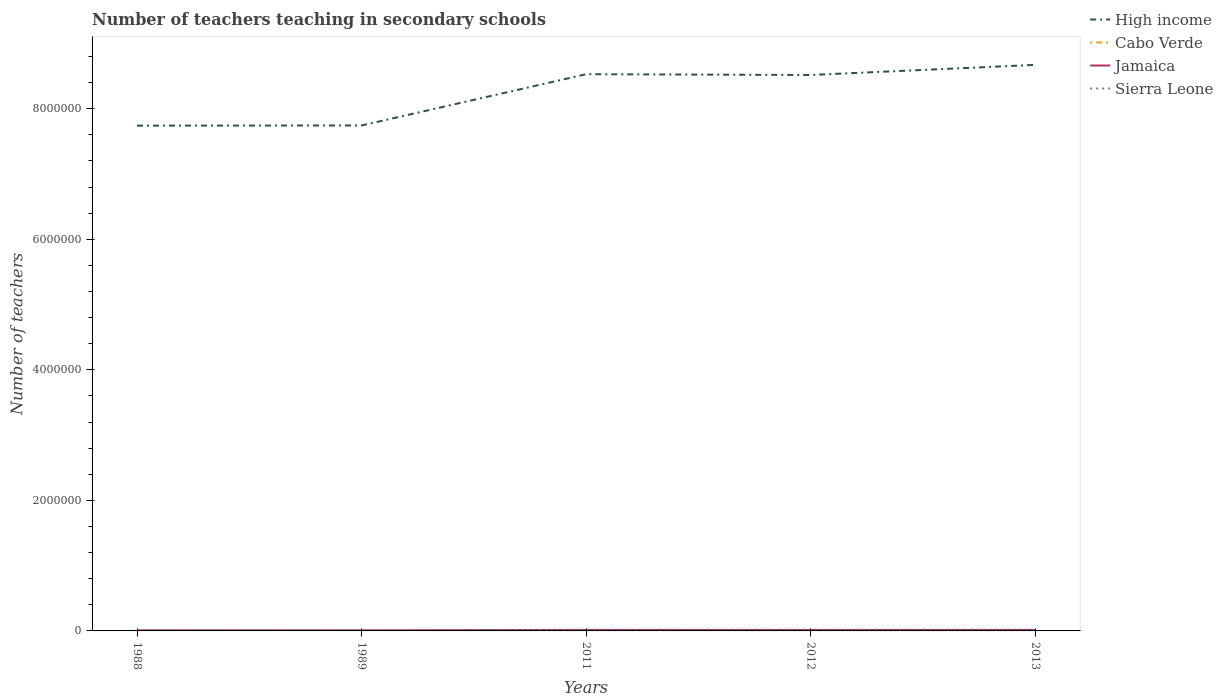How many different coloured lines are there?
Your response must be concise. 4. Does the line corresponding to High income intersect with the line corresponding to Jamaica?
Your answer should be very brief. No. Across all years, what is the maximum number of teachers teaching in secondary schools in Sierra Leone?
Provide a short and direct response. 5130. What is the total number of teachers teaching in secondary schools in High income in the graph?
Ensure brevity in your answer.  -9.28e+05. What is the difference between the highest and the second highest number of teachers teaching in secondary schools in Jamaica?
Provide a succinct answer. 6449. What is the difference between the highest and the lowest number of teachers teaching in secondary schools in Cabo Verde?
Offer a very short reply. 3. Does the graph contain any zero values?
Ensure brevity in your answer.  No. Does the graph contain grids?
Offer a very short reply. No. How many legend labels are there?
Offer a very short reply. 4. What is the title of the graph?
Your response must be concise. Number of teachers teaching in secondary schools. Does "Hungary" appear as one of the legend labels in the graph?
Make the answer very short. No. What is the label or title of the X-axis?
Your response must be concise. Years. What is the label or title of the Y-axis?
Offer a terse response. Number of teachers. What is the Number of teachers of High income in 1988?
Provide a succinct answer. 7.74e+06. What is the Number of teachers of Cabo Verde in 1988?
Keep it short and to the point. 268. What is the Number of teachers in Jamaica in 1988?
Your response must be concise. 9037. What is the Number of teachers of Sierra Leone in 1988?
Your response must be concise. 5820. What is the Number of teachers of High income in 1989?
Your answer should be compact. 7.74e+06. What is the Number of teachers of Cabo Verde in 1989?
Your answer should be very brief. 291. What is the Number of teachers of Jamaica in 1989?
Offer a terse response. 9061. What is the Number of teachers of Sierra Leone in 1989?
Keep it short and to the point. 5130. What is the Number of teachers of High income in 2011?
Make the answer very short. 8.53e+06. What is the Number of teachers in Cabo Verde in 2011?
Provide a short and direct response. 3614. What is the Number of teachers in Jamaica in 2011?
Offer a very short reply. 1.55e+04. What is the Number of teachers of Sierra Leone in 2011?
Keep it short and to the point. 1.72e+04. What is the Number of teachers of High income in 2012?
Your response must be concise. 8.52e+06. What is the Number of teachers of Cabo Verde in 2012?
Provide a succinct answer. 3689. What is the Number of teachers in Jamaica in 2012?
Your response must be concise. 1.43e+04. What is the Number of teachers in Sierra Leone in 2012?
Keep it short and to the point. 1.85e+04. What is the Number of teachers in High income in 2013?
Keep it short and to the point. 8.67e+06. What is the Number of teachers of Cabo Verde in 2013?
Keep it short and to the point. 3624. What is the Number of teachers of Jamaica in 2013?
Give a very brief answer. 1.42e+04. What is the Number of teachers in Sierra Leone in 2013?
Offer a terse response. 2.02e+04. Across all years, what is the maximum Number of teachers of High income?
Ensure brevity in your answer.  8.67e+06. Across all years, what is the maximum Number of teachers of Cabo Verde?
Provide a short and direct response. 3689. Across all years, what is the maximum Number of teachers of Jamaica?
Your response must be concise. 1.55e+04. Across all years, what is the maximum Number of teachers of Sierra Leone?
Keep it short and to the point. 2.02e+04. Across all years, what is the minimum Number of teachers of High income?
Offer a very short reply. 7.74e+06. Across all years, what is the minimum Number of teachers of Cabo Verde?
Your answer should be compact. 268. Across all years, what is the minimum Number of teachers in Jamaica?
Provide a succinct answer. 9037. Across all years, what is the minimum Number of teachers of Sierra Leone?
Your response must be concise. 5130. What is the total Number of teachers of High income in the graph?
Ensure brevity in your answer.  4.12e+07. What is the total Number of teachers of Cabo Verde in the graph?
Offer a terse response. 1.15e+04. What is the total Number of teachers in Jamaica in the graph?
Provide a succinct answer. 6.20e+04. What is the total Number of teachers of Sierra Leone in the graph?
Ensure brevity in your answer.  6.68e+04. What is the difference between the Number of teachers of High income in 1988 and that in 1989?
Your answer should be compact. -2848. What is the difference between the Number of teachers in Jamaica in 1988 and that in 1989?
Your response must be concise. -24. What is the difference between the Number of teachers in Sierra Leone in 1988 and that in 1989?
Make the answer very short. 690. What is the difference between the Number of teachers of High income in 1988 and that in 2011?
Keep it short and to the point. -7.88e+05. What is the difference between the Number of teachers of Cabo Verde in 1988 and that in 2011?
Your response must be concise. -3346. What is the difference between the Number of teachers in Jamaica in 1988 and that in 2011?
Ensure brevity in your answer.  -6449. What is the difference between the Number of teachers in Sierra Leone in 1988 and that in 2011?
Offer a very short reply. -1.14e+04. What is the difference between the Number of teachers of High income in 1988 and that in 2012?
Your answer should be compact. -7.76e+05. What is the difference between the Number of teachers of Cabo Verde in 1988 and that in 2012?
Provide a succinct answer. -3421. What is the difference between the Number of teachers of Jamaica in 1988 and that in 2012?
Provide a short and direct response. -5219. What is the difference between the Number of teachers in Sierra Leone in 1988 and that in 2012?
Ensure brevity in your answer.  -1.27e+04. What is the difference between the Number of teachers in High income in 1988 and that in 2013?
Offer a terse response. -9.31e+05. What is the difference between the Number of teachers in Cabo Verde in 1988 and that in 2013?
Provide a succinct answer. -3356. What is the difference between the Number of teachers in Jamaica in 1988 and that in 2013?
Provide a short and direct response. -5113. What is the difference between the Number of teachers of Sierra Leone in 1988 and that in 2013?
Give a very brief answer. -1.44e+04. What is the difference between the Number of teachers in High income in 1989 and that in 2011?
Your answer should be very brief. -7.85e+05. What is the difference between the Number of teachers of Cabo Verde in 1989 and that in 2011?
Your answer should be compact. -3323. What is the difference between the Number of teachers in Jamaica in 1989 and that in 2011?
Provide a short and direct response. -6425. What is the difference between the Number of teachers in Sierra Leone in 1989 and that in 2011?
Provide a short and direct response. -1.21e+04. What is the difference between the Number of teachers of High income in 1989 and that in 2012?
Make the answer very short. -7.73e+05. What is the difference between the Number of teachers in Cabo Verde in 1989 and that in 2012?
Give a very brief answer. -3398. What is the difference between the Number of teachers in Jamaica in 1989 and that in 2012?
Keep it short and to the point. -5195. What is the difference between the Number of teachers in Sierra Leone in 1989 and that in 2012?
Offer a terse response. -1.34e+04. What is the difference between the Number of teachers in High income in 1989 and that in 2013?
Provide a succinct answer. -9.28e+05. What is the difference between the Number of teachers in Cabo Verde in 1989 and that in 2013?
Your answer should be very brief. -3333. What is the difference between the Number of teachers in Jamaica in 1989 and that in 2013?
Ensure brevity in your answer.  -5089. What is the difference between the Number of teachers of Sierra Leone in 1989 and that in 2013?
Ensure brevity in your answer.  -1.51e+04. What is the difference between the Number of teachers in High income in 2011 and that in 2012?
Your response must be concise. 1.19e+04. What is the difference between the Number of teachers of Cabo Verde in 2011 and that in 2012?
Offer a very short reply. -75. What is the difference between the Number of teachers in Jamaica in 2011 and that in 2012?
Offer a terse response. 1230. What is the difference between the Number of teachers of Sierra Leone in 2011 and that in 2012?
Offer a very short reply. -1288. What is the difference between the Number of teachers in High income in 2011 and that in 2013?
Offer a terse response. -1.43e+05. What is the difference between the Number of teachers of Cabo Verde in 2011 and that in 2013?
Your response must be concise. -10. What is the difference between the Number of teachers of Jamaica in 2011 and that in 2013?
Your answer should be very brief. 1336. What is the difference between the Number of teachers of Sierra Leone in 2011 and that in 2013?
Your answer should be compact. -3002. What is the difference between the Number of teachers in High income in 2012 and that in 2013?
Provide a short and direct response. -1.55e+05. What is the difference between the Number of teachers of Jamaica in 2012 and that in 2013?
Offer a terse response. 106. What is the difference between the Number of teachers in Sierra Leone in 2012 and that in 2013?
Your answer should be very brief. -1714. What is the difference between the Number of teachers in High income in 1988 and the Number of teachers in Cabo Verde in 1989?
Your response must be concise. 7.74e+06. What is the difference between the Number of teachers in High income in 1988 and the Number of teachers in Jamaica in 1989?
Provide a succinct answer. 7.73e+06. What is the difference between the Number of teachers of High income in 1988 and the Number of teachers of Sierra Leone in 1989?
Keep it short and to the point. 7.74e+06. What is the difference between the Number of teachers of Cabo Verde in 1988 and the Number of teachers of Jamaica in 1989?
Your answer should be compact. -8793. What is the difference between the Number of teachers of Cabo Verde in 1988 and the Number of teachers of Sierra Leone in 1989?
Your answer should be compact. -4862. What is the difference between the Number of teachers in Jamaica in 1988 and the Number of teachers in Sierra Leone in 1989?
Offer a very short reply. 3907. What is the difference between the Number of teachers of High income in 1988 and the Number of teachers of Cabo Verde in 2011?
Give a very brief answer. 7.74e+06. What is the difference between the Number of teachers in High income in 1988 and the Number of teachers in Jamaica in 2011?
Keep it short and to the point. 7.72e+06. What is the difference between the Number of teachers in High income in 1988 and the Number of teachers in Sierra Leone in 2011?
Offer a terse response. 7.72e+06. What is the difference between the Number of teachers of Cabo Verde in 1988 and the Number of teachers of Jamaica in 2011?
Make the answer very short. -1.52e+04. What is the difference between the Number of teachers of Cabo Verde in 1988 and the Number of teachers of Sierra Leone in 2011?
Offer a terse response. -1.69e+04. What is the difference between the Number of teachers in Jamaica in 1988 and the Number of teachers in Sierra Leone in 2011?
Your answer should be very brief. -8157. What is the difference between the Number of teachers in High income in 1988 and the Number of teachers in Cabo Verde in 2012?
Keep it short and to the point. 7.74e+06. What is the difference between the Number of teachers of High income in 1988 and the Number of teachers of Jamaica in 2012?
Provide a succinct answer. 7.73e+06. What is the difference between the Number of teachers in High income in 1988 and the Number of teachers in Sierra Leone in 2012?
Give a very brief answer. 7.72e+06. What is the difference between the Number of teachers in Cabo Verde in 1988 and the Number of teachers in Jamaica in 2012?
Offer a terse response. -1.40e+04. What is the difference between the Number of teachers in Cabo Verde in 1988 and the Number of teachers in Sierra Leone in 2012?
Offer a very short reply. -1.82e+04. What is the difference between the Number of teachers of Jamaica in 1988 and the Number of teachers of Sierra Leone in 2012?
Offer a very short reply. -9445. What is the difference between the Number of teachers in High income in 1988 and the Number of teachers in Cabo Verde in 2013?
Offer a very short reply. 7.74e+06. What is the difference between the Number of teachers of High income in 1988 and the Number of teachers of Jamaica in 2013?
Provide a succinct answer. 7.73e+06. What is the difference between the Number of teachers of High income in 1988 and the Number of teachers of Sierra Leone in 2013?
Offer a terse response. 7.72e+06. What is the difference between the Number of teachers in Cabo Verde in 1988 and the Number of teachers in Jamaica in 2013?
Provide a short and direct response. -1.39e+04. What is the difference between the Number of teachers in Cabo Verde in 1988 and the Number of teachers in Sierra Leone in 2013?
Keep it short and to the point. -1.99e+04. What is the difference between the Number of teachers in Jamaica in 1988 and the Number of teachers in Sierra Leone in 2013?
Provide a short and direct response. -1.12e+04. What is the difference between the Number of teachers of High income in 1989 and the Number of teachers of Cabo Verde in 2011?
Provide a succinct answer. 7.74e+06. What is the difference between the Number of teachers of High income in 1989 and the Number of teachers of Jamaica in 2011?
Your answer should be very brief. 7.73e+06. What is the difference between the Number of teachers in High income in 1989 and the Number of teachers in Sierra Leone in 2011?
Offer a very short reply. 7.73e+06. What is the difference between the Number of teachers of Cabo Verde in 1989 and the Number of teachers of Jamaica in 2011?
Make the answer very short. -1.52e+04. What is the difference between the Number of teachers of Cabo Verde in 1989 and the Number of teachers of Sierra Leone in 2011?
Your answer should be compact. -1.69e+04. What is the difference between the Number of teachers in Jamaica in 1989 and the Number of teachers in Sierra Leone in 2011?
Provide a succinct answer. -8133. What is the difference between the Number of teachers in High income in 1989 and the Number of teachers in Cabo Verde in 2012?
Ensure brevity in your answer.  7.74e+06. What is the difference between the Number of teachers in High income in 1989 and the Number of teachers in Jamaica in 2012?
Offer a terse response. 7.73e+06. What is the difference between the Number of teachers in High income in 1989 and the Number of teachers in Sierra Leone in 2012?
Ensure brevity in your answer.  7.72e+06. What is the difference between the Number of teachers in Cabo Verde in 1989 and the Number of teachers in Jamaica in 2012?
Provide a succinct answer. -1.40e+04. What is the difference between the Number of teachers of Cabo Verde in 1989 and the Number of teachers of Sierra Leone in 2012?
Give a very brief answer. -1.82e+04. What is the difference between the Number of teachers of Jamaica in 1989 and the Number of teachers of Sierra Leone in 2012?
Your answer should be compact. -9421. What is the difference between the Number of teachers of High income in 1989 and the Number of teachers of Cabo Verde in 2013?
Your answer should be compact. 7.74e+06. What is the difference between the Number of teachers of High income in 1989 and the Number of teachers of Jamaica in 2013?
Ensure brevity in your answer.  7.73e+06. What is the difference between the Number of teachers of High income in 1989 and the Number of teachers of Sierra Leone in 2013?
Offer a very short reply. 7.72e+06. What is the difference between the Number of teachers of Cabo Verde in 1989 and the Number of teachers of Jamaica in 2013?
Provide a succinct answer. -1.39e+04. What is the difference between the Number of teachers of Cabo Verde in 1989 and the Number of teachers of Sierra Leone in 2013?
Provide a succinct answer. -1.99e+04. What is the difference between the Number of teachers of Jamaica in 1989 and the Number of teachers of Sierra Leone in 2013?
Ensure brevity in your answer.  -1.11e+04. What is the difference between the Number of teachers in High income in 2011 and the Number of teachers in Cabo Verde in 2012?
Your answer should be very brief. 8.52e+06. What is the difference between the Number of teachers of High income in 2011 and the Number of teachers of Jamaica in 2012?
Your answer should be very brief. 8.51e+06. What is the difference between the Number of teachers in High income in 2011 and the Number of teachers in Sierra Leone in 2012?
Make the answer very short. 8.51e+06. What is the difference between the Number of teachers of Cabo Verde in 2011 and the Number of teachers of Jamaica in 2012?
Offer a very short reply. -1.06e+04. What is the difference between the Number of teachers in Cabo Verde in 2011 and the Number of teachers in Sierra Leone in 2012?
Your response must be concise. -1.49e+04. What is the difference between the Number of teachers in Jamaica in 2011 and the Number of teachers in Sierra Leone in 2012?
Give a very brief answer. -2996. What is the difference between the Number of teachers of High income in 2011 and the Number of teachers of Cabo Verde in 2013?
Your answer should be compact. 8.52e+06. What is the difference between the Number of teachers of High income in 2011 and the Number of teachers of Jamaica in 2013?
Provide a short and direct response. 8.51e+06. What is the difference between the Number of teachers in High income in 2011 and the Number of teachers in Sierra Leone in 2013?
Offer a very short reply. 8.51e+06. What is the difference between the Number of teachers of Cabo Verde in 2011 and the Number of teachers of Jamaica in 2013?
Provide a succinct answer. -1.05e+04. What is the difference between the Number of teachers of Cabo Verde in 2011 and the Number of teachers of Sierra Leone in 2013?
Ensure brevity in your answer.  -1.66e+04. What is the difference between the Number of teachers in Jamaica in 2011 and the Number of teachers in Sierra Leone in 2013?
Your answer should be compact. -4710. What is the difference between the Number of teachers of High income in 2012 and the Number of teachers of Cabo Verde in 2013?
Your answer should be compact. 8.51e+06. What is the difference between the Number of teachers of High income in 2012 and the Number of teachers of Jamaica in 2013?
Your answer should be compact. 8.50e+06. What is the difference between the Number of teachers in High income in 2012 and the Number of teachers in Sierra Leone in 2013?
Give a very brief answer. 8.50e+06. What is the difference between the Number of teachers of Cabo Verde in 2012 and the Number of teachers of Jamaica in 2013?
Your answer should be very brief. -1.05e+04. What is the difference between the Number of teachers in Cabo Verde in 2012 and the Number of teachers in Sierra Leone in 2013?
Offer a terse response. -1.65e+04. What is the difference between the Number of teachers of Jamaica in 2012 and the Number of teachers of Sierra Leone in 2013?
Provide a succinct answer. -5940. What is the average Number of teachers of High income per year?
Give a very brief answer. 8.24e+06. What is the average Number of teachers of Cabo Verde per year?
Keep it short and to the point. 2297.2. What is the average Number of teachers of Jamaica per year?
Your answer should be very brief. 1.24e+04. What is the average Number of teachers in Sierra Leone per year?
Your answer should be very brief. 1.34e+04. In the year 1988, what is the difference between the Number of teachers in High income and Number of teachers in Cabo Verde?
Your answer should be very brief. 7.74e+06. In the year 1988, what is the difference between the Number of teachers in High income and Number of teachers in Jamaica?
Give a very brief answer. 7.73e+06. In the year 1988, what is the difference between the Number of teachers of High income and Number of teachers of Sierra Leone?
Offer a terse response. 7.73e+06. In the year 1988, what is the difference between the Number of teachers of Cabo Verde and Number of teachers of Jamaica?
Provide a succinct answer. -8769. In the year 1988, what is the difference between the Number of teachers of Cabo Verde and Number of teachers of Sierra Leone?
Your response must be concise. -5552. In the year 1988, what is the difference between the Number of teachers in Jamaica and Number of teachers in Sierra Leone?
Ensure brevity in your answer.  3217. In the year 1989, what is the difference between the Number of teachers in High income and Number of teachers in Cabo Verde?
Your response must be concise. 7.74e+06. In the year 1989, what is the difference between the Number of teachers of High income and Number of teachers of Jamaica?
Provide a short and direct response. 7.73e+06. In the year 1989, what is the difference between the Number of teachers in High income and Number of teachers in Sierra Leone?
Keep it short and to the point. 7.74e+06. In the year 1989, what is the difference between the Number of teachers of Cabo Verde and Number of teachers of Jamaica?
Make the answer very short. -8770. In the year 1989, what is the difference between the Number of teachers of Cabo Verde and Number of teachers of Sierra Leone?
Keep it short and to the point. -4839. In the year 1989, what is the difference between the Number of teachers in Jamaica and Number of teachers in Sierra Leone?
Provide a short and direct response. 3931. In the year 2011, what is the difference between the Number of teachers of High income and Number of teachers of Cabo Verde?
Your answer should be very brief. 8.52e+06. In the year 2011, what is the difference between the Number of teachers in High income and Number of teachers in Jamaica?
Offer a very short reply. 8.51e+06. In the year 2011, what is the difference between the Number of teachers of High income and Number of teachers of Sierra Leone?
Your answer should be compact. 8.51e+06. In the year 2011, what is the difference between the Number of teachers of Cabo Verde and Number of teachers of Jamaica?
Provide a short and direct response. -1.19e+04. In the year 2011, what is the difference between the Number of teachers in Cabo Verde and Number of teachers in Sierra Leone?
Your answer should be very brief. -1.36e+04. In the year 2011, what is the difference between the Number of teachers of Jamaica and Number of teachers of Sierra Leone?
Keep it short and to the point. -1708. In the year 2012, what is the difference between the Number of teachers of High income and Number of teachers of Cabo Verde?
Give a very brief answer. 8.51e+06. In the year 2012, what is the difference between the Number of teachers in High income and Number of teachers in Jamaica?
Give a very brief answer. 8.50e+06. In the year 2012, what is the difference between the Number of teachers in High income and Number of teachers in Sierra Leone?
Your answer should be compact. 8.50e+06. In the year 2012, what is the difference between the Number of teachers in Cabo Verde and Number of teachers in Jamaica?
Make the answer very short. -1.06e+04. In the year 2012, what is the difference between the Number of teachers in Cabo Verde and Number of teachers in Sierra Leone?
Make the answer very short. -1.48e+04. In the year 2012, what is the difference between the Number of teachers of Jamaica and Number of teachers of Sierra Leone?
Your answer should be compact. -4226. In the year 2013, what is the difference between the Number of teachers of High income and Number of teachers of Cabo Verde?
Make the answer very short. 8.67e+06. In the year 2013, what is the difference between the Number of teachers of High income and Number of teachers of Jamaica?
Your answer should be very brief. 8.66e+06. In the year 2013, what is the difference between the Number of teachers of High income and Number of teachers of Sierra Leone?
Keep it short and to the point. 8.65e+06. In the year 2013, what is the difference between the Number of teachers in Cabo Verde and Number of teachers in Jamaica?
Offer a very short reply. -1.05e+04. In the year 2013, what is the difference between the Number of teachers in Cabo Verde and Number of teachers in Sierra Leone?
Your answer should be very brief. -1.66e+04. In the year 2013, what is the difference between the Number of teachers in Jamaica and Number of teachers in Sierra Leone?
Provide a short and direct response. -6046. What is the ratio of the Number of teachers in High income in 1988 to that in 1989?
Ensure brevity in your answer.  1. What is the ratio of the Number of teachers of Cabo Verde in 1988 to that in 1989?
Your answer should be compact. 0.92. What is the ratio of the Number of teachers of Sierra Leone in 1988 to that in 1989?
Ensure brevity in your answer.  1.13. What is the ratio of the Number of teachers of High income in 1988 to that in 2011?
Your answer should be compact. 0.91. What is the ratio of the Number of teachers in Cabo Verde in 1988 to that in 2011?
Ensure brevity in your answer.  0.07. What is the ratio of the Number of teachers of Jamaica in 1988 to that in 2011?
Offer a very short reply. 0.58. What is the ratio of the Number of teachers of Sierra Leone in 1988 to that in 2011?
Your answer should be very brief. 0.34. What is the ratio of the Number of teachers of High income in 1988 to that in 2012?
Your response must be concise. 0.91. What is the ratio of the Number of teachers of Cabo Verde in 1988 to that in 2012?
Your answer should be very brief. 0.07. What is the ratio of the Number of teachers of Jamaica in 1988 to that in 2012?
Provide a succinct answer. 0.63. What is the ratio of the Number of teachers of Sierra Leone in 1988 to that in 2012?
Ensure brevity in your answer.  0.31. What is the ratio of the Number of teachers of High income in 1988 to that in 2013?
Make the answer very short. 0.89. What is the ratio of the Number of teachers in Cabo Verde in 1988 to that in 2013?
Offer a very short reply. 0.07. What is the ratio of the Number of teachers in Jamaica in 1988 to that in 2013?
Offer a very short reply. 0.64. What is the ratio of the Number of teachers of Sierra Leone in 1988 to that in 2013?
Make the answer very short. 0.29. What is the ratio of the Number of teachers of High income in 1989 to that in 2011?
Your answer should be very brief. 0.91. What is the ratio of the Number of teachers of Cabo Verde in 1989 to that in 2011?
Make the answer very short. 0.08. What is the ratio of the Number of teachers of Jamaica in 1989 to that in 2011?
Your answer should be compact. 0.59. What is the ratio of the Number of teachers of Sierra Leone in 1989 to that in 2011?
Make the answer very short. 0.3. What is the ratio of the Number of teachers of High income in 1989 to that in 2012?
Keep it short and to the point. 0.91. What is the ratio of the Number of teachers in Cabo Verde in 1989 to that in 2012?
Your answer should be compact. 0.08. What is the ratio of the Number of teachers in Jamaica in 1989 to that in 2012?
Your response must be concise. 0.64. What is the ratio of the Number of teachers of Sierra Leone in 1989 to that in 2012?
Your answer should be compact. 0.28. What is the ratio of the Number of teachers of High income in 1989 to that in 2013?
Make the answer very short. 0.89. What is the ratio of the Number of teachers of Cabo Verde in 1989 to that in 2013?
Provide a short and direct response. 0.08. What is the ratio of the Number of teachers in Jamaica in 1989 to that in 2013?
Make the answer very short. 0.64. What is the ratio of the Number of teachers in Sierra Leone in 1989 to that in 2013?
Your answer should be compact. 0.25. What is the ratio of the Number of teachers of High income in 2011 to that in 2012?
Your response must be concise. 1. What is the ratio of the Number of teachers in Cabo Verde in 2011 to that in 2012?
Give a very brief answer. 0.98. What is the ratio of the Number of teachers in Jamaica in 2011 to that in 2012?
Offer a terse response. 1.09. What is the ratio of the Number of teachers of Sierra Leone in 2011 to that in 2012?
Your answer should be compact. 0.93. What is the ratio of the Number of teachers in High income in 2011 to that in 2013?
Make the answer very short. 0.98. What is the ratio of the Number of teachers of Cabo Verde in 2011 to that in 2013?
Your answer should be very brief. 1. What is the ratio of the Number of teachers of Jamaica in 2011 to that in 2013?
Offer a very short reply. 1.09. What is the ratio of the Number of teachers in Sierra Leone in 2011 to that in 2013?
Give a very brief answer. 0.85. What is the ratio of the Number of teachers in High income in 2012 to that in 2013?
Ensure brevity in your answer.  0.98. What is the ratio of the Number of teachers in Cabo Verde in 2012 to that in 2013?
Keep it short and to the point. 1.02. What is the ratio of the Number of teachers of Jamaica in 2012 to that in 2013?
Provide a short and direct response. 1.01. What is the ratio of the Number of teachers in Sierra Leone in 2012 to that in 2013?
Provide a short and direct response. 0.92. What is the difference between the highest and the second highest Number of teachers of High income?
Make the answer very short. 1.43e+05. What is the difference between the highest and the second highest Number of teachers in Cabo Verde?
Offer a terse response. 65. What is the difference between the highest and the second highest Number of teachers of Jamaica?
Your response must be concise. 1230. What is the difference between the highest and the second highest Number of teachers in Sierra Leone?
Ensure brevity in your answer.  1714. What is the difference between the highest and the lowest Number of teachers of High income?
Provide a succinct answer. 9.31e+05. What is the difference between the highest and the lowest Number of teachers in Cabo Verde?
Your answer should be compact. 3421. What is the difference between the highest and the lowest Number of teachers in Jamaica?
Provide a succinct answer. 6449. What is the difference between the highest and the lowest Number of teachers of Sierra Leone?
Keep it short and to the point. 1.51e+04. 